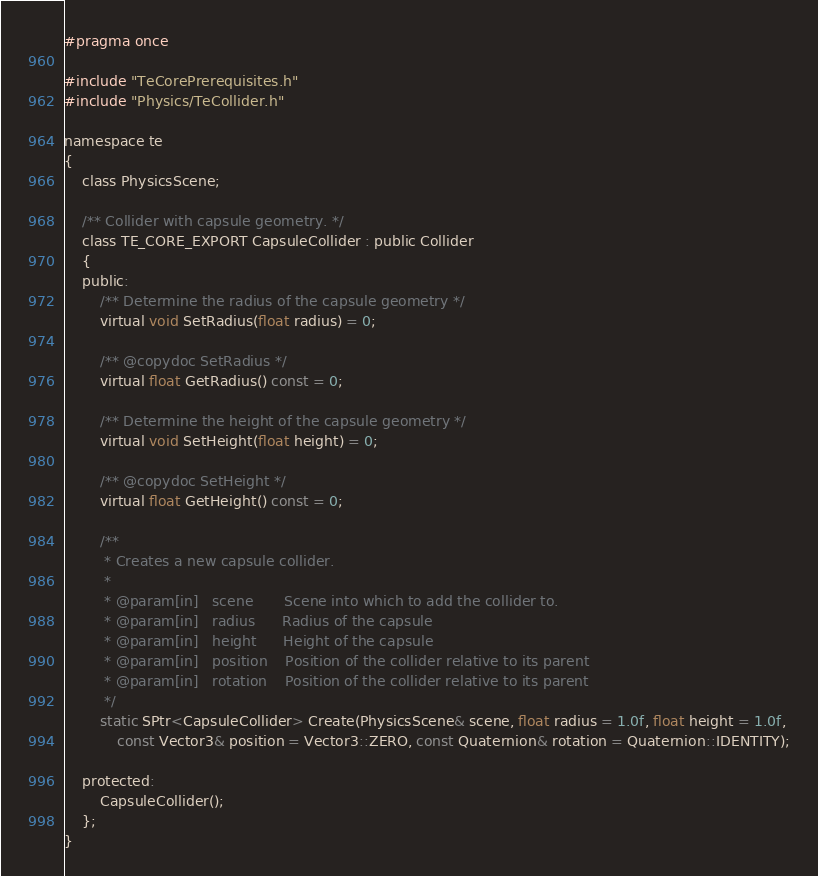Convert code to text. <code><loc_0><loc_0><loc_500><loc_500><_C_>#pragma once

#include "TeCorePrerequisites.h"
#include "Physics/TeCollider.h"

namespace te
{
    class PhysicsScene;

    /** Collider with capsule geometry. */
    class TE_CORE_EXPORT CapsuleCollider : public Collider
    {
    public:
        /** Determine the radius of the capsule geometry */
        virtual void SetRadius(float radius) = 0;

        /** @copydoc SetRadius */
        virtual float GetRadius() const = 0;

        /** Determine the height of the capsule geometry */
        virtual void SetHeight(float height) = 0;

        /** @copydoc SetHeight */
        virtual float GetHeight() const = 0;

        /**
         * Creates a new capsule collider.
         *
         * @param[in]	scene		Scene into which to add the collider to.
         * @param[in]	radius		Radius of the capsule
         * @param[in]	height		Height of the capsule
		 * @param[in]	position	Position of the collider relative to its parent
		 * @param[in]	rotation	Position of the collider relative to its parent
         */
        static SPtr<CapsuleCollider> Create(PhysicsScene& scene, float radius = 1.0f, float height = 1.0f, 
            const Vector3& position = Vector3::ZERO, const Quaternion& rotation = Quaternion::IDENTITY);

    protected:
        CapsuleCollider();
    };
}
</code> 